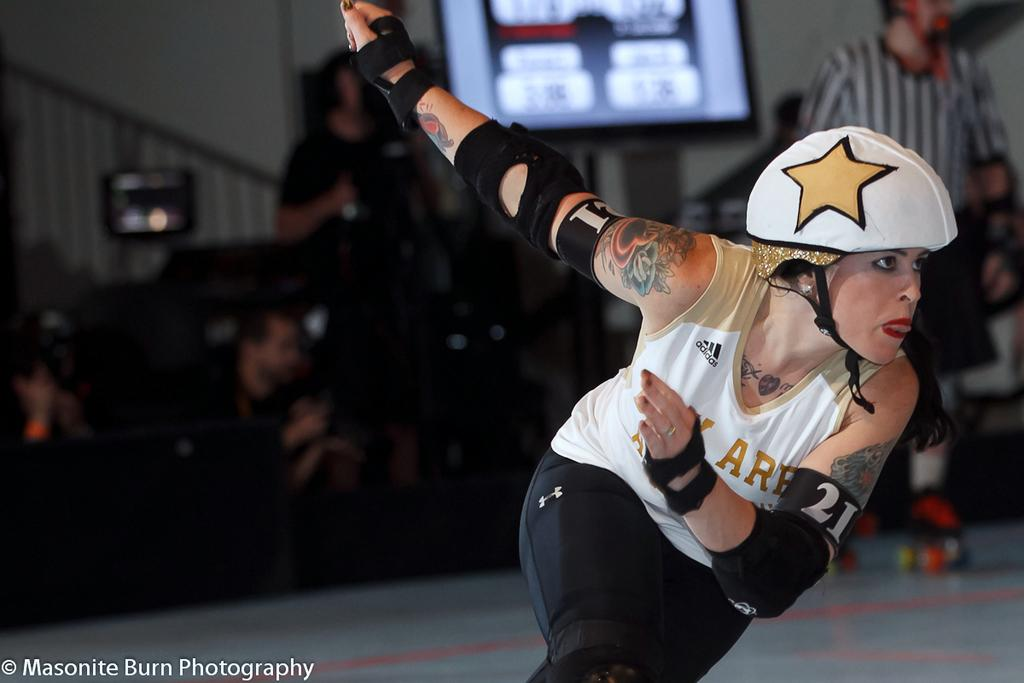Who is the main subject in the image? There is a girl in the image. What is the girl wearing? The girl is wearing a helmet. What activity is the girl engaged in? The girl is skating. Can you describe the other person in the image? The other person is wearing skating shoes. What can be seen in the background of the image? There are people in the background of the image. What type of object is the image displayed on? The image is a screen. What is the only architectural feature visible in the image? There is a wall in the image. How many bubbles are floating around the girl in the image? There are no bubbles present in the image. What type of tin is the girl holding in the image? There is no tin present in the image. 